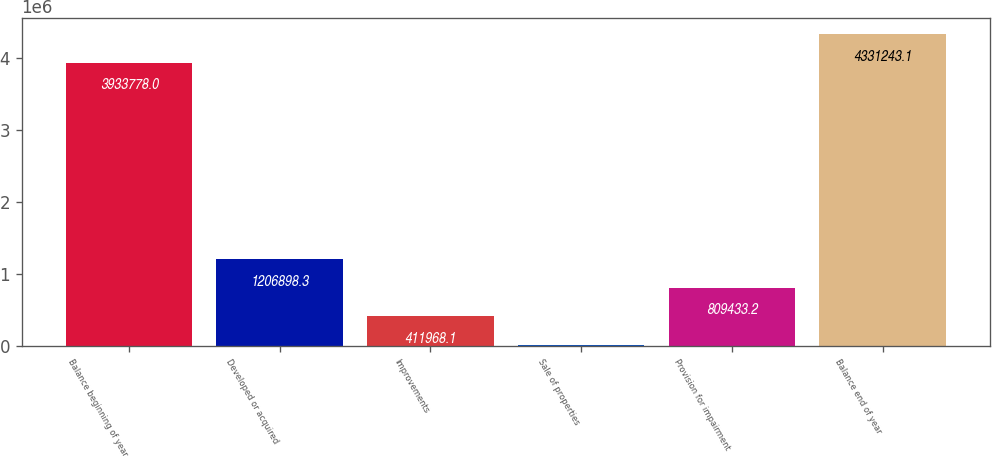Convert chart. <chart><loc_0><loc_0><loc_500><loc_500><bar_chart><fcel>Balance beginning of year<fcel>Developed or acquired<fcel>Improvements<fcel>Sale of properties<fcel>Provision for impairment<fcel>Balance end of year<nl><fcel>3.93378e+06<fcel>1.2069e+06<fcel>411968<fcel>14503<fcel>809433<fcel>4.33124e+06<nl></chart> 